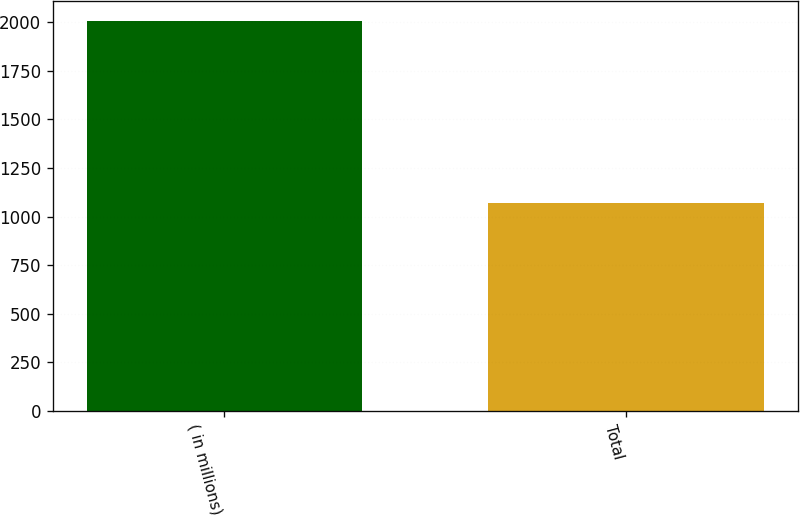Convert chart. <chart><loc_0><loc_0><loc_500><loc_500><bar_chart><fcel>( in millions)<fcel>Total<nl><fcel>2008<fcel>1072<nl></chart> 